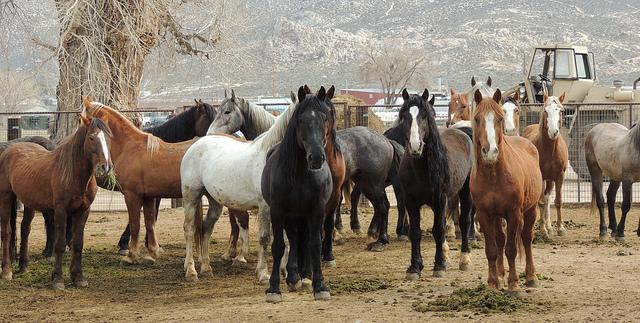What is the name of the fenced off area for these horses? corral 